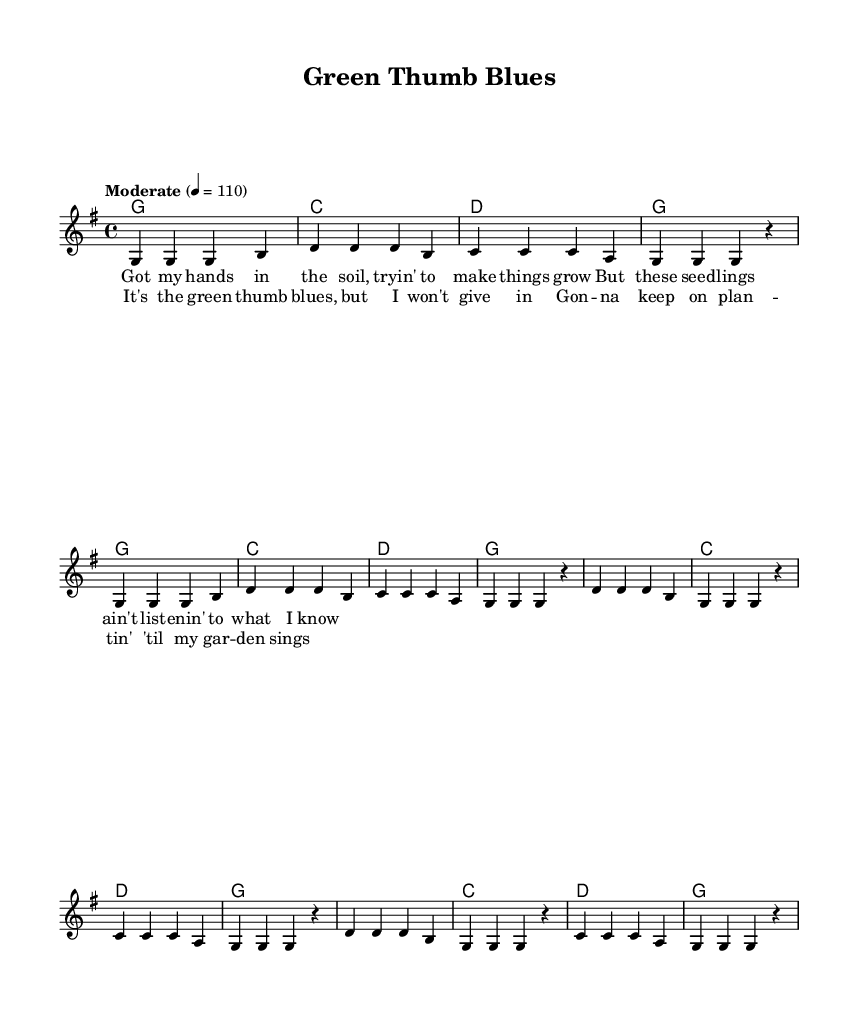What is the key signature of this music? The key signature is identified at the beginning of the score, showing one sharp (F#). It indicates the tonal center of the piece, which is G major.
Answer: G major What is the time signature of this music? The time signature is located at the beginning of the score, expressing how many beats are in each measure. Here, it states 4/4, which means there are four beats per measure.
Answer: 4/4 What is the tempo marking for this piece? The tempo marking is found at the beginning, specifying the pace of the music. It states "Moderate" with a metronome marking of 110 beats per minute, indicating a moderate speed.
Answer: Moderate How many measures are there in the verse section? To find the number of measures in the verse, you count the individual sections in the melody and harmonies labeled as "Verse." Here, there are 8 measures in total, consisting of two repetitions of the verse section.
Answer: 8 What is the primary theme of the lyrics in the chorus? Examining the lyrics in the chorus, they focus on perseverance despite challenges, as expressed in the lines about keeping on planting until the garden thrives. This highlights the central theme of dedication in gardening.
Answer: Perseverance How do the verse and chorus sections differ in terms of melody range? To answer this, you inspect the melody notes in both the verse and chorus. The verse mainly revolves around the notes G and D, while the chorus expands to higher notes like D, showcasing an upward range that conveys emotion, portraying the loftiness of hope versus the grounded nature of the verse.
Answer: Melody range shifts higher in the chorus What is the structure of the song based on the provided music? The structure is determined by identifying the repetition of sections. Here, it follows a pattern of Verse - Chorus - Verse - Chorus, indicating a simple yet effective songwriting format typical of country rock.
Answer: Verse - Chorus - Verse - Chorus 